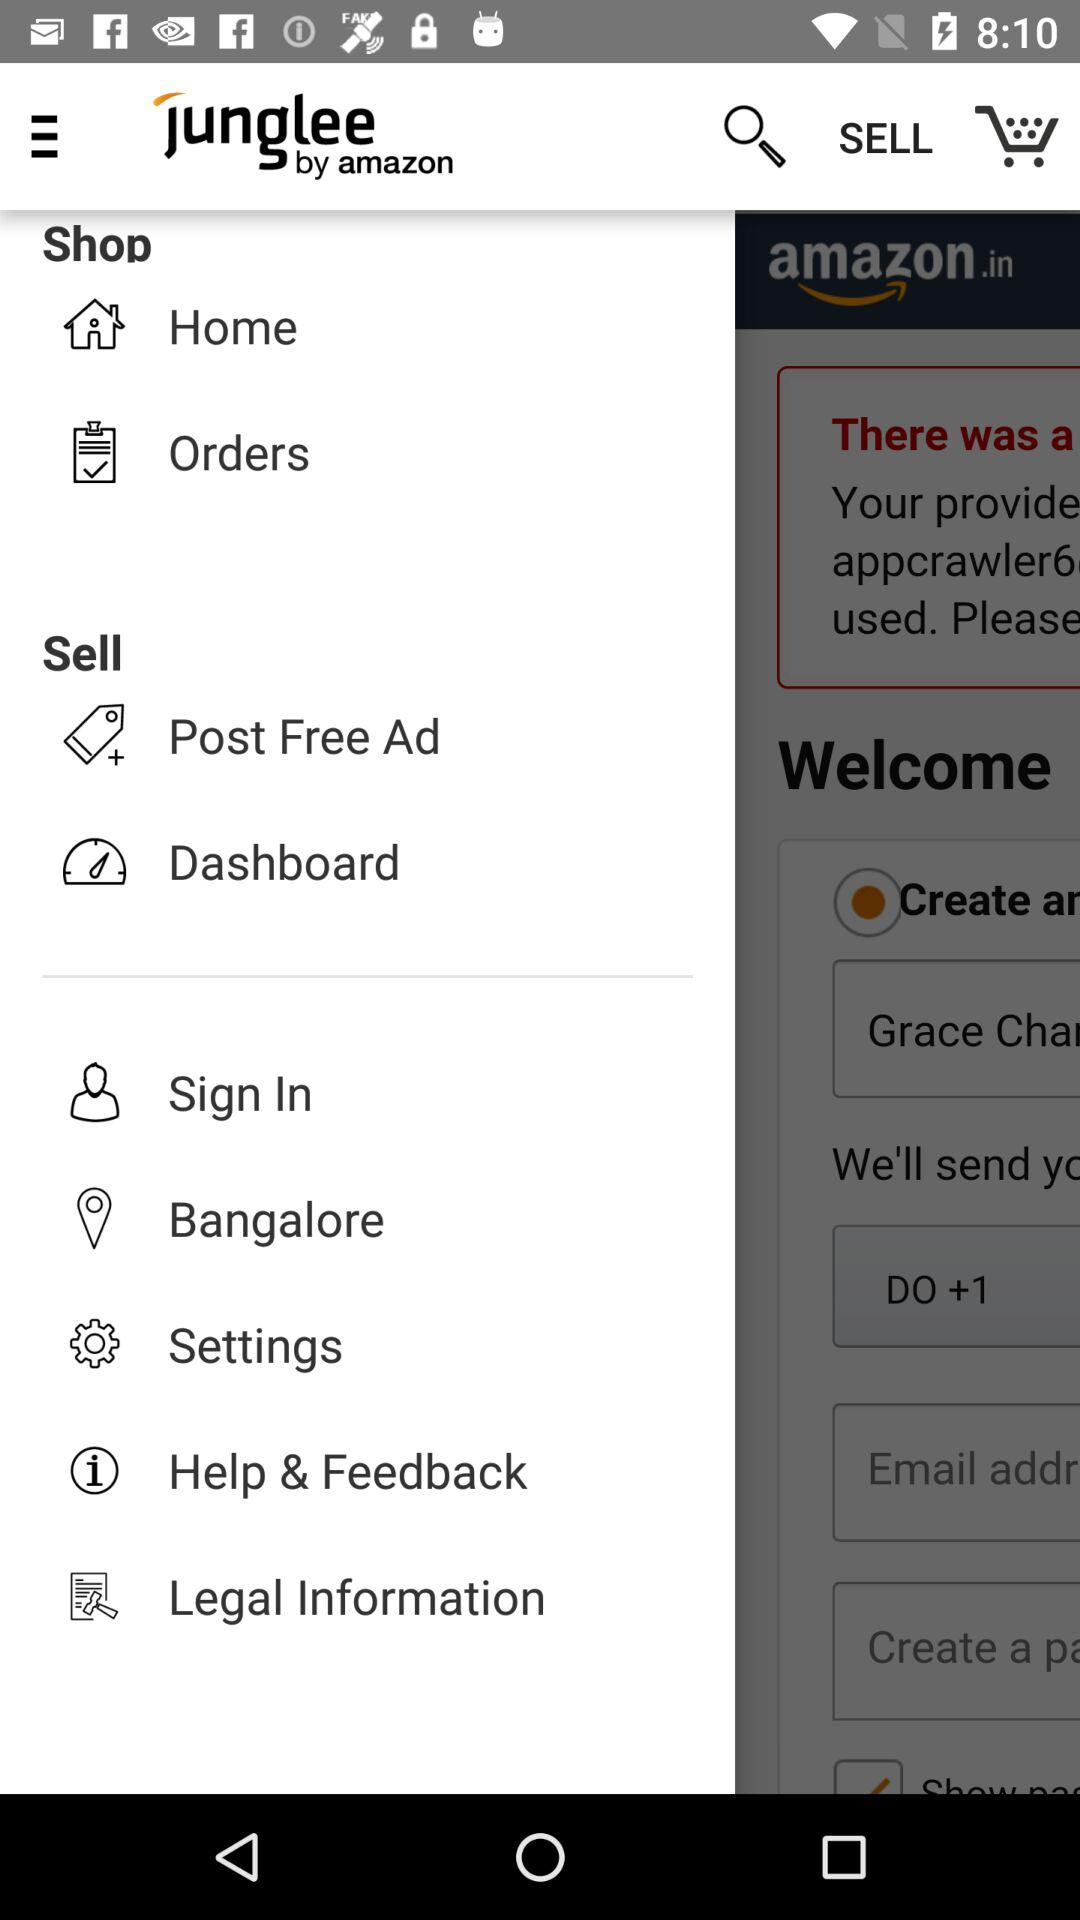What is the application name? The application name is "junglee by amazon". 